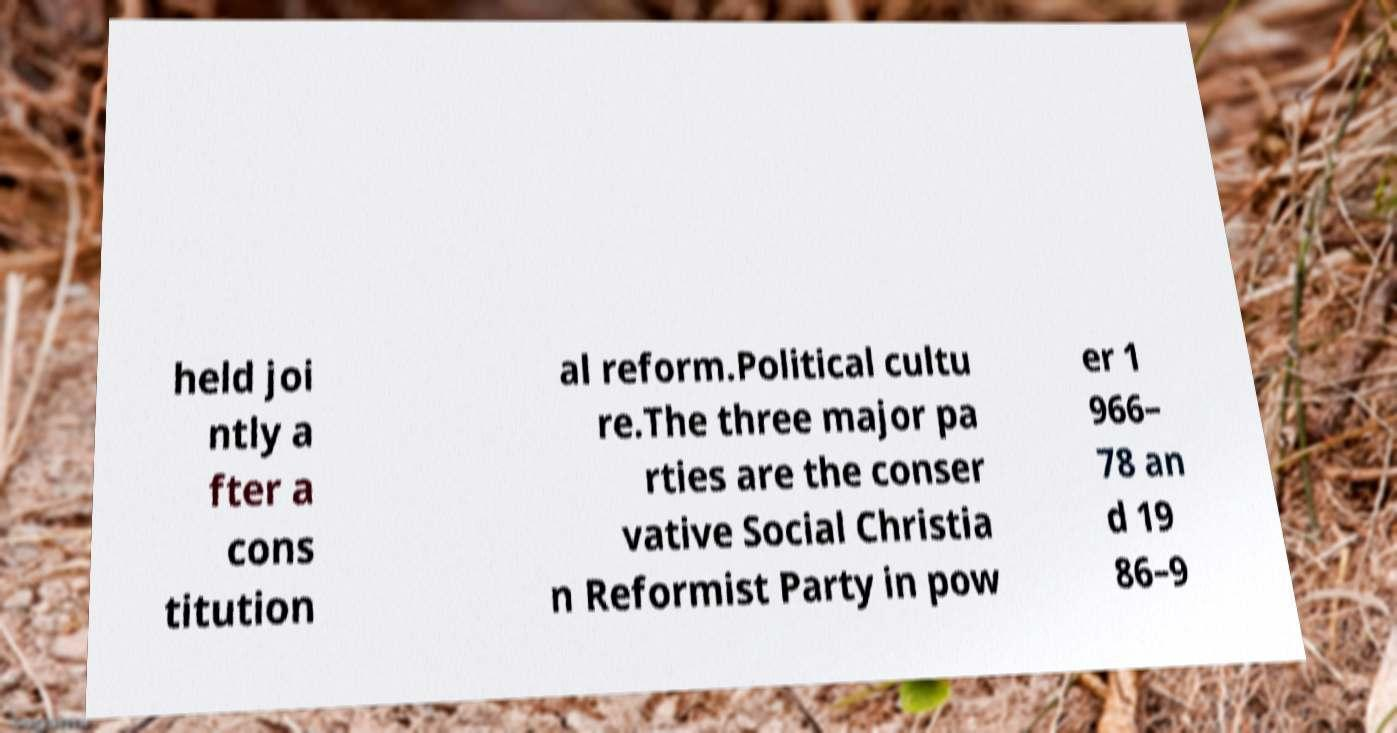Please read and relay the text visible in this image. What does it say? held joi ntly a fter a cons titution al reform.Political cultu re.The three major pa rties are the conser vative Social Christia n Reformist Party in pow er 1 966– 78 an d 19 86–9 